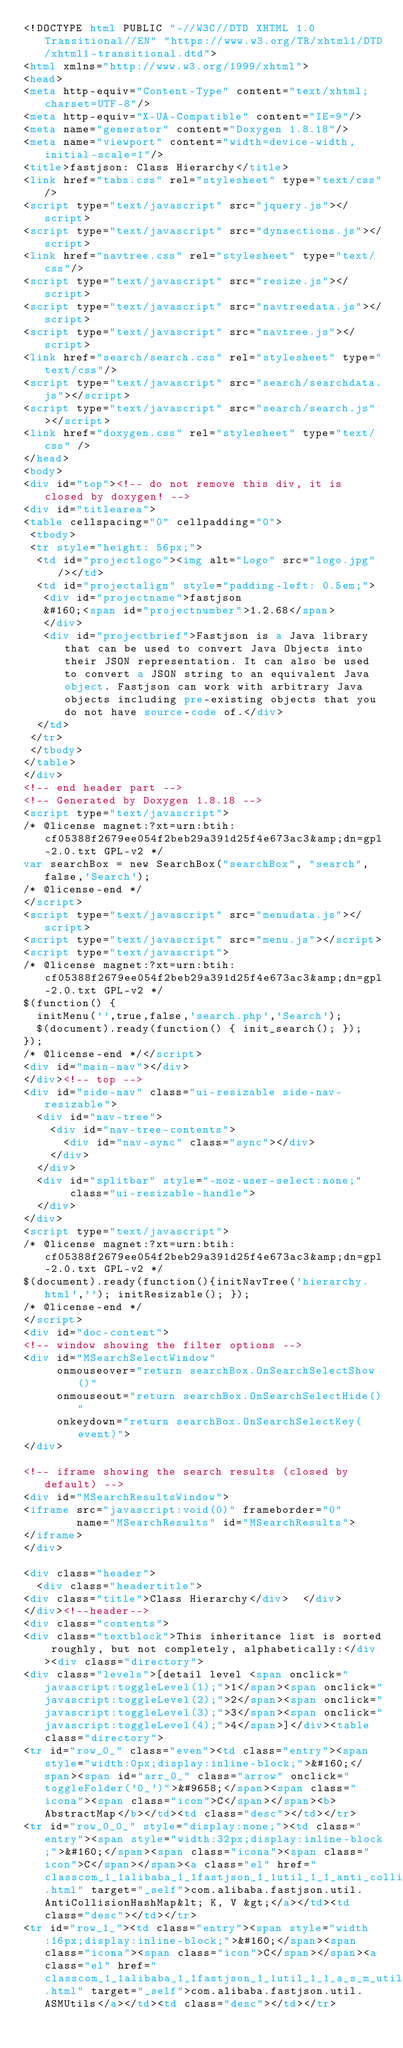<code> <loc_0><loc_0><loc_500><loc_500><_HTML_><!DOCTYPE html PUBLIC "-//W3C//DTD XHTML 1.0 Transitional//EN" "https://www.w3.org/TR/xhtml1/DTD/xhtml1-transitional.dtd">
<html xmlns="http://www.w3.org/1999/xhtml">
<head>
<meta http-equiv="Content-Type" content="text/xhtml;charset=UTF-8"/>
<meta http-equiv="X-UA-Compatible" content="IE=9"/>
<meta name="generator" content="Doxygen 1.8.18"/>
<meta name="viewport" content="width=device-width, initial-scale=1"/>
<title>fastjson: Class Hierarchy</title>
<link href="tabs.css" rel="stylesheet" type="text/css"/>
<script type="text/javascript" src="jquery.js"></script>
<script type="text/javascript" src="dynsections.js"></script>
<link href="navtree.css" rel="stylesheet" type="text/css"/>
<script type="text/javascript" src="resize.js"></script>
<script type="text/javascript" src="navtreedata.js"></script>
<script type="text/javascript" src="navtree.js"></script>
<link href="search/search.css" rel="stylesheet" type="text/css"/>
<script type="text/javascript" src="search/searchdata.js"></script>
<script type="text/javascript" src="search/search.js"></script>
<link href="doxygen.css" rel="stylesheet" type="text/css" />
</head>
<body>
<div id="top"><!-- do not remove this div, it is closed by doxygen! -->
<div id="titlearea">
<table cellspacing="0" cellpadding="0">
 <tbody>
 <tr style="height: 56px;">
  <td id="projectlogo"><img alt="Logo" src="logo.jpg"/></td>
  <td id="projectalign" style="padding-left: 0.5em;">
   <div id="projectname">fastjson
   &#160;<span id="projectnumber">1.2.68</span>
   </div>
   <div id="projectbrief">Fastjson is a Java library that can be used to convert Java Objects into their JSON representation. It can also be used to convert a JSON string to an equivalent Java object. Fastjson can work with arbitrary Java objects including pre-existing objects that you do not have source-code of.</div>
  </td>
 </tr>
 </tbody>
</table>
</div>
<!-- end header part -->
<!-- Generated by Doxygen 1.8.18 -->
<script type="text/javascript">
/* @license magnet:?xt=urn:btih:cf05388f2679ee054f2beb29a391d25f4e673ac3&amp;dn=gpl-2.0.txt GPL-v2 */
var searchBox = new SearchBox("searchBox", "search",false,'Search');
/* @license-end */
</script>
<script type="text/javascript" src="menudata.js"></script>
<script type="text/javascript" src="menu.js"></script>
<script type="text/javascript">
/* @license magnet:?xt=urn:btih:cf05388f2679ee054f2beb29a391d25f4e673ac3&amp;dn=gpl-2.0.txt GPL-v2 */
$(function() {
  initMenu('',true,false,'search.php','Search');
  $(document).ready(function() { init_search(); });
});
/* @license-end */</script>
<div id="main-nav"></div>
</div><!-- top -->
<div id="side-nav" class="ui-resizable side-nav-resizable">
  <div id="nav-tree">
    <div id="nav-tree-contents">
      <div id="nav-sync" class="sync"></div>
    </div>
  </div>
  <div id="splitbar" style="-moz-user-select:none;" 
       class="ui-resizable-handle">
  </div>
</div>
<script type="text/javascript">
/* @license magnet:?xt=urn:btih:cf05388f2679ee054f2beb29a391d25f4e673ac3&amp;dn=gpl-2.0.txt GPL-v2 */
$(document).ready(function(){initNavTree('hierarchy.html',''); initResizable(); });
/* @license-end */
</script>
<div id="doc-content">
<!-- window showing the filter options -->
<div id="MSearchSelectWindow"
     onmouseover="return searchBox.OnSearchSelectShow()"
     onmouseout="return searchBox.OnSearchSelectHide()"
     onkeydown="return searchBox.OnSearchSelectKey(event)">
</div>

<!-- iframe showing the search results (closed by default) -->
<div id="MSearchResultsWindow">
<iframe src="javascript:void(0)" frameborder="0" 
        name="MSearchResults" id="MSearchResults">
</iframe>
</div>

<div class="header">
  <div class="headertitle">
<div class="title">Class Hierarchy</div>  </div>
</div><!--header-->
<div class="contents">
<div class="textblock">This inheritance list is sorted roughly, but not completely, alphabetically:</div><div class="directory">
<div class="levels">[detail level <span onclick="javascript:toggleLevel(1);">1</span><span onclick="javascript:toggleLevel(2);">2</span><span onclick="javascript:toggleLevel(3);">3</span><span onclick="javascript:toggleLevel(4);">4</span>]</div><table class="directory">
<tr id="row_0_" class="even"><td class="entry"><span style="width:0px;display:inline-block;">&#160;</span><span id="arr_0_" class="arrow" onclick="toggleFolder('0_')">&#9658;</span><span class="icona"><span class="icon">C</span></span><b>AbstractMap</b></td><td class="desc"></td></tr>
<tr id="row_0_0_" style="display:none;"><td class="entry"><span style="width:32px;display:inline-block;">&#160;</span><span class="icona"><span class="icon">C</span></span><a class="el" href="classcom_1_1alibaba_1_1fastjson_1_1util_1_1_anti_collision_hash_map.html" target="_self">com.alibaba.fastjson.util.AntiCollisionHashMap&lt; K, V &gt;</a></td><td class="desc"></td></tr>
<tr id="row_1_"><td class="entry"><span style="width:16px;display:inline-block;">&#160;</span><span class="icona"><span class="icon">C</span></span><a class="el" href="classcom_1_1alibaba_1_1fastjson_1_1util_1_1_a_s_m_utils.html" target="_self">com.alibaba.fastjson.util.ASMUtils</a></td><td class="desc"></td></tr></code> 